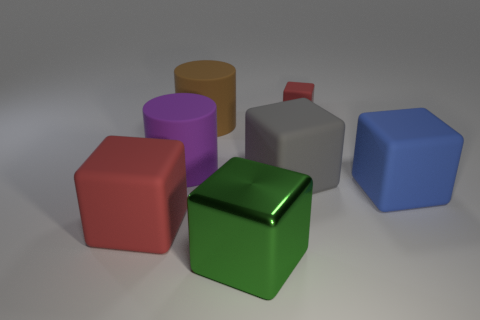What is the material of the green thing?
Your response must be concise. Metal. There is a green thing that is the same shape as the gray rubber thing; what size is it?
Make the answer very short. Large. How many other objects are there of the same material as the blue thing?
Provide a short and direct response. 5. Do the large blue cube and the block that is in front of the big red matte object have the same material?
Your answer should be compact. No. Are there fewer big brown cylinders that are left of the large purple cylinder than large gray objects in front of the shiny thing?
Your answer should be very brief. No. There is a matte cylinder that is left of the big brown matte object; what is its color?
Your answer should be very brief. Purple. What number of other objects are the same color as the big metallic block?
Provide a short and direct response. 0. Is the size of the red rubber block that is to the left of the green metal thing the same as the big blue object?
Your response must be concise. Yes. How many large brown cylinders are to the right of the large green shiny thing?
Offer a terse response. 0. Is there a yellow shiny cube of the same size as the green metal block?
Your answer should be very brief. No. 